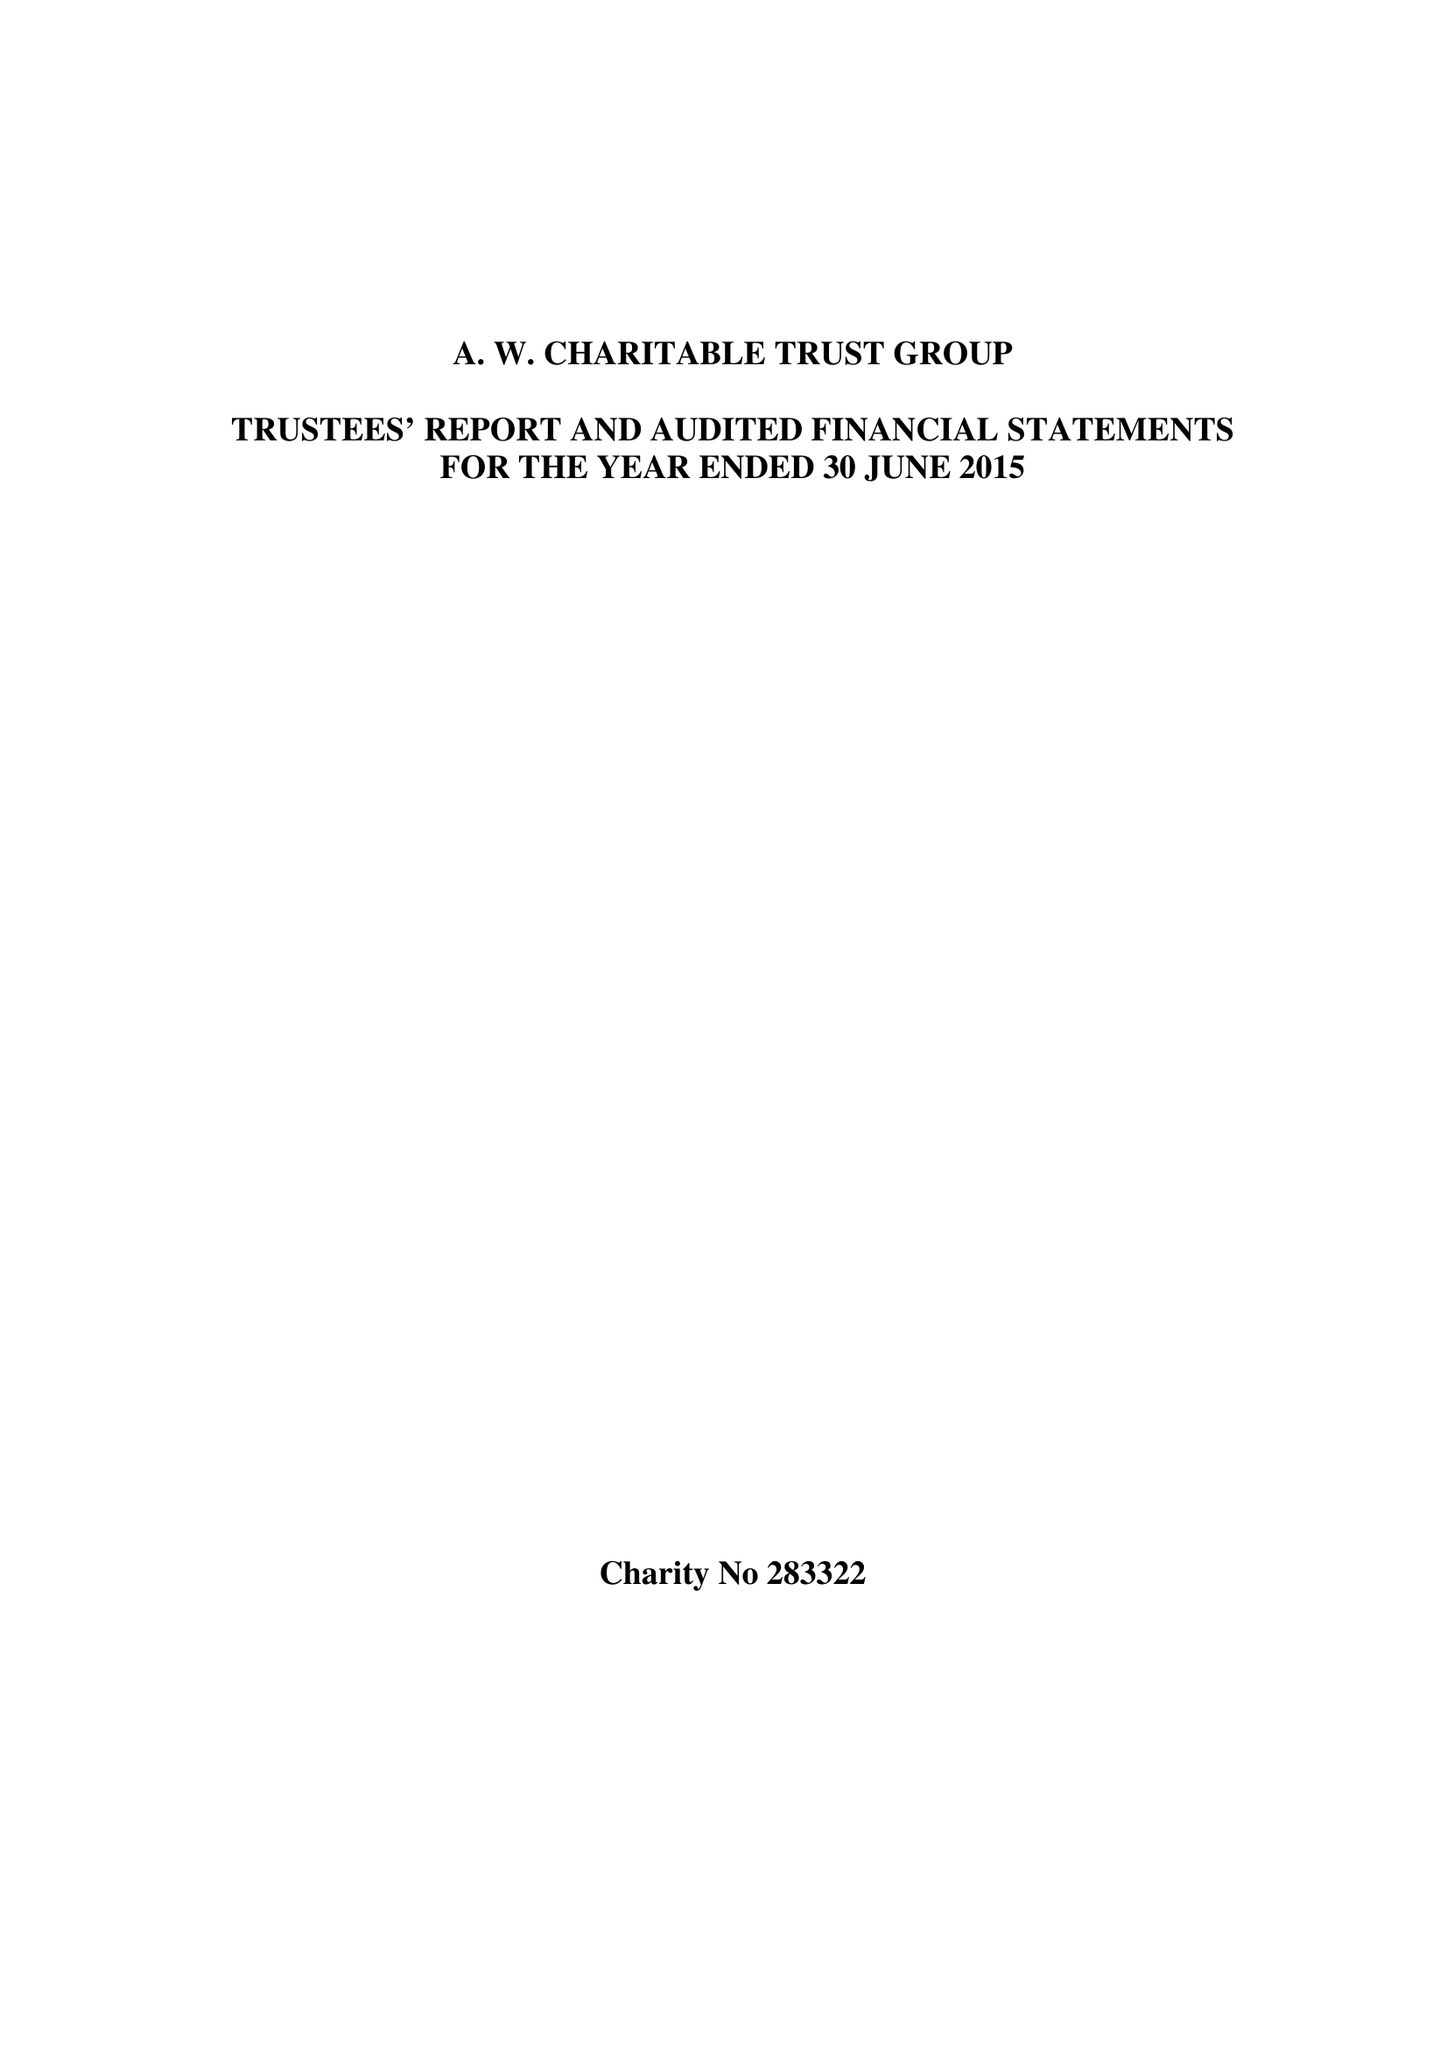What is the value for the charity_number?
Answer the question using a single word or phrase. 283322 